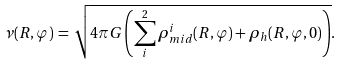<formula> <loc_0><loc_0><loc_500><loc_500>\nu ( R , \varphi ) \, = \, \sqrt { 4 \pi G \left ( \sum _ { i } ^ { 2 } \rho _ { m i d } ^ { i } ( R , \varphi ) + \rho _ { h } ( R , \varphi , 0 ) \right ) } .</formula> 